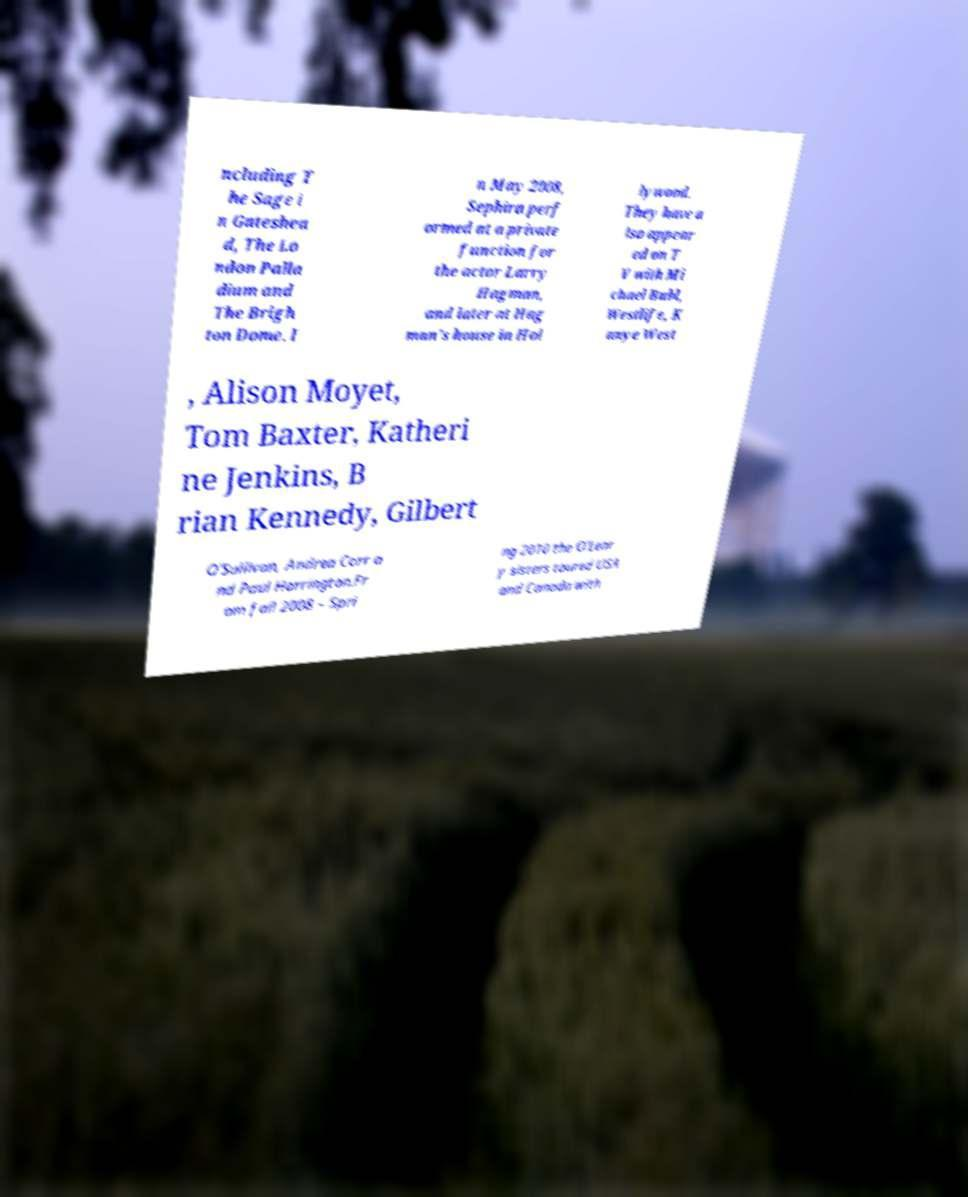What messages or text are displayed in this image? I need them in a readable, typed format. ncluding T he Sage i n Gateshea d, The Lo ndon Palla dium and The Brigh ton Dome. I n May 2008, Sephira perf ormed at a private function for the actor Larry Hagman, and later at Hag man's house in Hol lywood. They have a lso appear ed on T V with Mi chael Bubl, Westlife, K anye West , Alison Moyet, Tom Baxter, Katheri ne Jenkins, B rian Kennedy, Gilbert O'Sullivan, Andrea Corr a nd Paul Harrington.Fr om fall 2008 – Spri ng 2010 the O'Lear y sisters toured USA and Canada with 